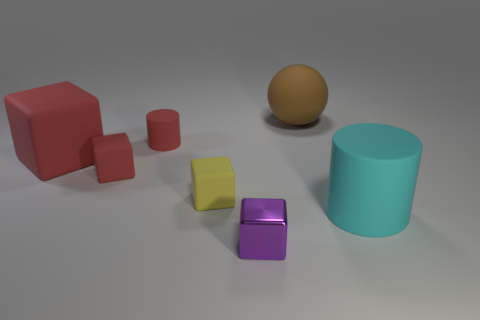What number of tiny blue cylinders are made of the same material as the small red cylinder?
Keep it short and to the point. 0. Is the number of red cubes less than the number of small red balls?
Give a very brief answer. No. Is the material of the tiny object that is in front of the large cyan matte thing the same as the brown sphere?
Ensure brevity in your answer.  No. What number of cylinders are either small red things or large matte objects?
Provide a succinct answer. 2. The large rubber object that is to the right of the yellow object and behind the large cyan matte cylinder has what shape?
Offer a very short reply. Sphere. There is a thing that is to the left of the red rubber block that is on the right side of the big matte object that is left of the purple block; what is its color?
Keep it short and to the point. Red. Is the number of large red blocks that are in front of the cyan cylinder less than the number of large cyan rubber cylinders?
Your response must be concise. Yes. Do the small object that is behind the big red matte object and the small red thing in front of the red cylinder have the same shape?
Keep it short and to the point. No. How many objects are either tiny cubes that are on the right side of the yellow block or big brown metallic things?
Give a very brief answer. 1. There is a big thing that is the same color as the small matte cylinder; what is its material?
Offer a very short reply. Rubber. 